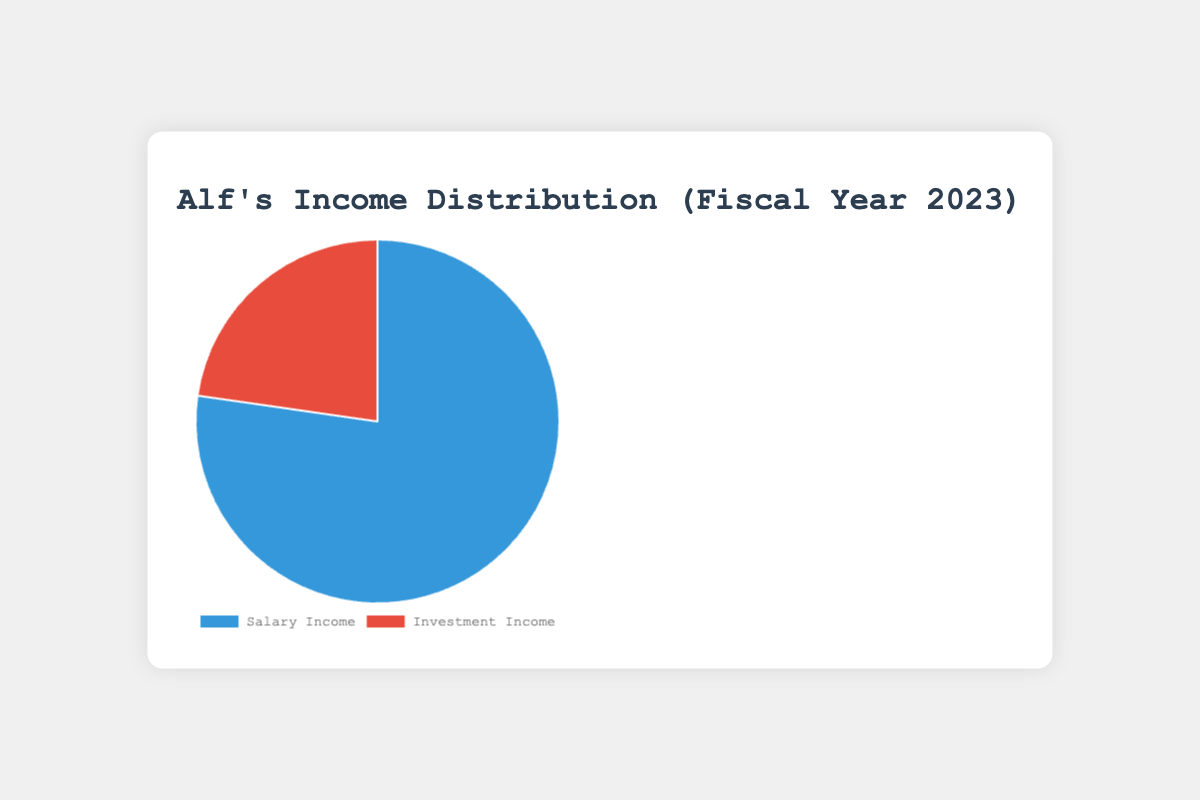How much of Alf's total income comes from his salary? The figure shows a pie chart with salary income and investment income. The salary income segment is labeled $85,000.
Answer: $85,000 How much of Alf's total income comes from investments? The pie chart shows two segments, one of which represents investment income labeled $25,000.
Answer: $25,000 What is the total income of Alf in the fiscal year 2023? The total income is the sum of salary income and investment income: $85,000 (salary) + $25,000 (investment).
Answer: $110,000 Which income source is the largest? By observing the size of the pie chart segments, the blue segment labeled salary income is larger than the red segment labeled investment income.
Answer: Salary income What percentage of Alf's total income is from investments? The investment income of $25,000 is divided by the total income of $110,000 and then multiplied by 100 to get the percentage: (25,000 / 110,000) * 100 ≈ 22.73%.
Answer: 22.73% What is the ratio of salary income to investment income? The ratio of salary income ($85,000) to investment income ($25,000) is 85,000:25,000, which simplifies to 85:25 or 17:5.
Answer: 17:5 What percentage of Alf's total income comes from his salary? The salary income of $85,000 is divided by the total income of $110,000 and then multiplied by 100 to get the percentage: (85,000 / 110,000) * 100 ≈ 77.27%.
Answer: 77.27% By how much does Alf's salary income exceed his investment income? The difference between salary income ($85,000) and investment income ($25,000) is calculated as follows: $85,000 - $25,000 = $60,000.
Answer: $60,000 If each dollar from salary income is represented by a blue segment, what color represents investment income? By observing the pie chart, the segment representing investment income is colored red.
Answer: Red 